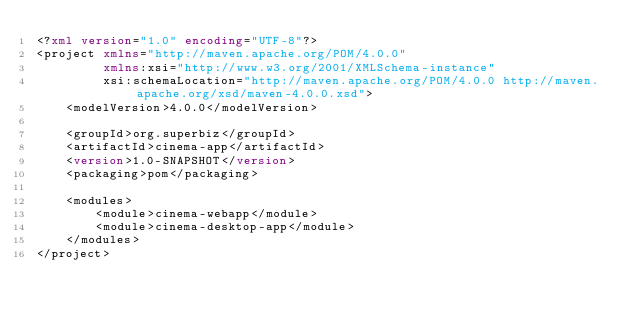<code> <loc_0><loc_0><loc_500><loc_500><_XML_><?xml version="1.0" encoding="UTF-8"?>
<project xmlns="http://maven.apache.org/POM/4.0.0"
         xmlns:xsi="http://www.w3.org/2001/XMLSchema-instance"
         xsi:schemaLocation="http://maven.apache.org/POM/4.0.0 http://maven.apache.org/xsd/maven-4.0.0.xsd">
    <modelVersion>4.0.0</modelVersion>

    <groupId>org.superbiz</groupId>
    <artifactId>cinema-app</artifactId>
    <version>1.0-SNAPSHOT</version>
    <packaging>pom</packaging>

    <modules>
        <module>cinema-webapp</module>
        <module>cinema-desktop-app</module>
    </modules>
</project></code> 